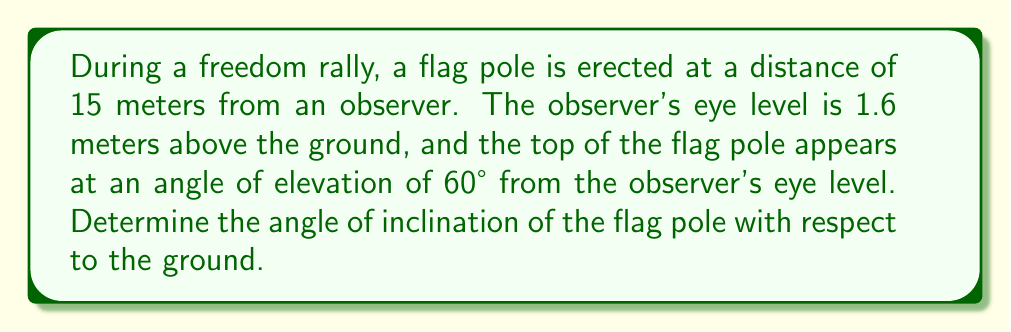Show me your answer to this math problem. Let's approach this step-by-step:

1) First, let's visualize the problem:

[asy]
import geometry;

size(200);
pair A = (0,0), B = (15,0), C = (15,1.6), D = (15,15);
draw(A--B--D--A);
draw(A--C);
draw(B--C,dashed);

label("Observer", A, W);
label("Flag pole", B, S);
label("15 m", (A--B), S);
label("1.6 m", (B--C), E);
label("60°", A, NE);
label("θ", B, NW);

markangle(B,A,D,Arrow);
markangle(C,B,D,Arrow);
[/asy]

2) We can see that this forms a right triangle. Let's call the angle of inclination θ.

3) We know:
   - The distance from the observer to the flag pole is 15 meters
   - The observer's eye level is 1.6 meters above the ground
   - The angle of elevation to the top of the flag pole is 60°

4) In the large triangle:
   $\tan 60° = \frac{\text{height of pole} - 1.6}{15}$

5) We can calculate the height of the pole:
   $\text{height of pole} = 15 \tan 60° + 1.6$
   $= 15 \cdot \sqrt{3} + 1.6 \approx 27.58$ meters

6) Now we have a right triangle with:
   - Base = 15 meters
   - Height = 27.58 meters

7) We can find θ using the tangent function:
   $\tan \theta = \frac{27.58}{15}$

8) Therefore:
   $\theta = \arctan(\frac{27.58}{15}) \approx 61.47°$
Answer: $61.47°$ 